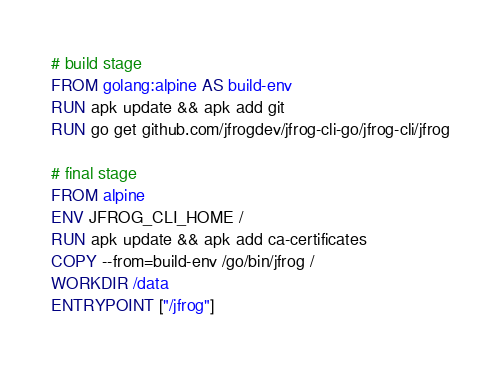<code> <loc_0><loc_0><loc_500><loc_500><_Dockerfile_># build stage
FROM golang:alpine AS build-env
RUN apk update && apk add git
RUN go get github.com/jfrogdev/jfrog-cli-go/jfrog-cli/jfrog

# final stage
FROM alpine
ENV JFROG_CLI_HOME /
RUN apk update && apk add ca-certificates
COPY --from=build-env /go/bin/jfrog /
WORKDIR /data
ENTRYPOINT ["/jfrog"]
</code> 